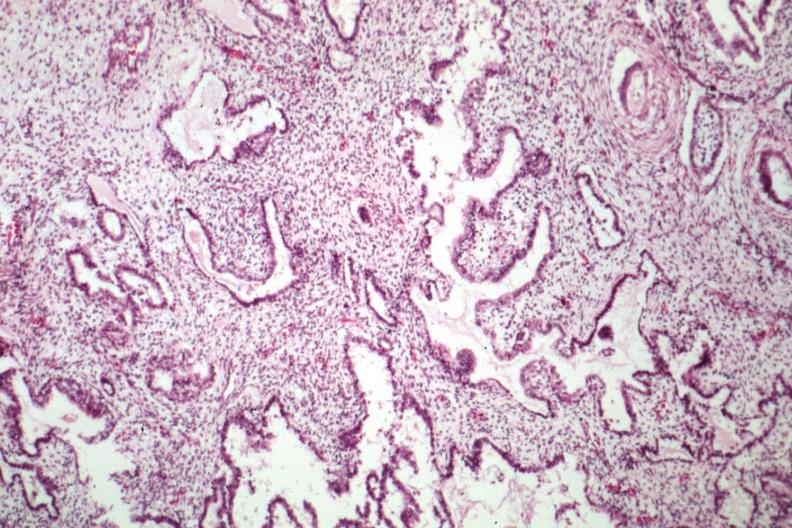s sacrococcygeal teratoma present?
Answer the question using a single word or phrase. Yes 